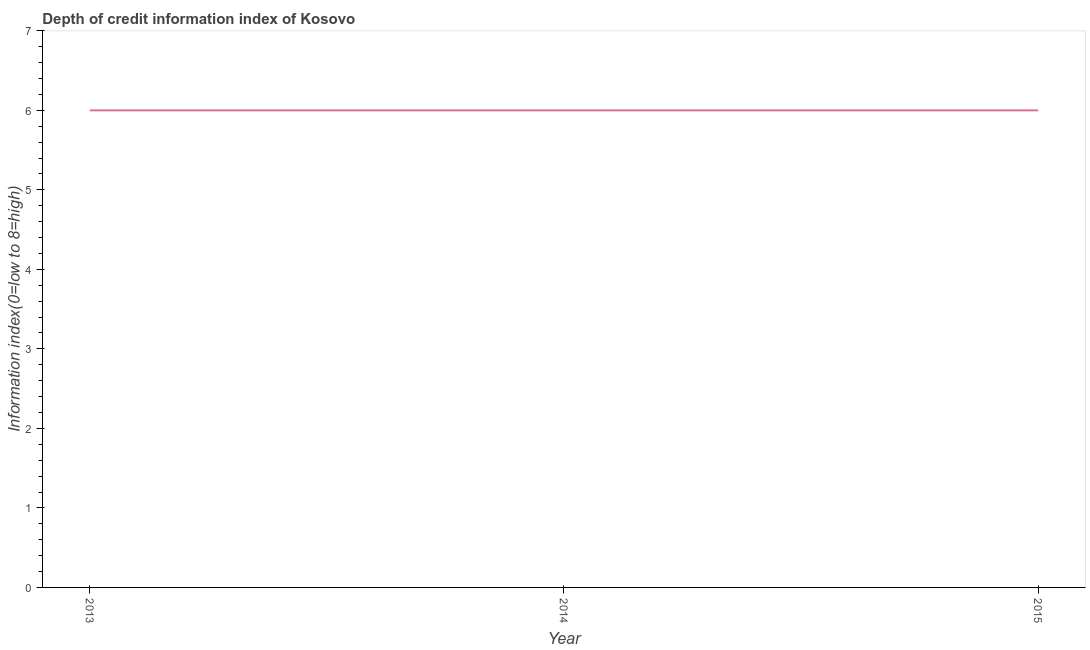What is the sum of the depth of credit information index?
Keep it short and to the point. 18. What is the difference between the depth of credit information index in 2013 and 2014?
Keep it short and to the point. 0. What is the average depth of credit information index per year?
Offer a very short reply. 6. What is the median depth of credit information index?
Provide a short and direct response. 6. Do a majority of the years between 2013 and 2014 (inclusive) have depth of credit information index greater than 2.8 ?
Offer a terse response. Yes. What is the ratio of the depth of credit information index in 2013 to that in 2014?
Provide a short and direct response. 1. Is the depth of credit information index in 2014 less than that in 2015?
Your response must be concise. No. What is the difference between the highest and the second highest depth of credit information index?
Your answer should be compact. 0. Is the sum of the depth of credit information index in 2013 and 2014 greater than the maximum depth of credit information index across all years?
Ensure brevity in your answer.  Yes. Does the depth of credit information index monotonically increase over the years?
Ensure brevity in your answer.  No. How many years are there in the graph?
Make the answer very short. 3. What is the difference between two consecutive major ticks on the Y-axis?
Ensure brevity in your answer.  1. Does the graph contain grids?
Offer a terse response. No. What is the title of the graph?
Provide a succinct answer. Depth of credit information index of Kosovo. What is the label or title of the X-axis?
Give a very brief answer. Year. What is the label or title of the Y-axis?
Provide a short and direct response. Information index(0=low to 8=high). What is the Information index(0=low to 8=high) of 2013?
Your response must be concise. 6. What is the Information index(0=low to 8=high) in 2015?
Make the answer very short. 6. What is the ratio of the Information index(0=low to 8=high) in 2013 to that in 2014?
Your response must be concise. 1. 